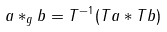Convert formula to latex. <formula><loc_0><loc_0><loc_500><loc_500>a * _ { g } b = T ^ { - 1 } ( T a * T b )</formula> 